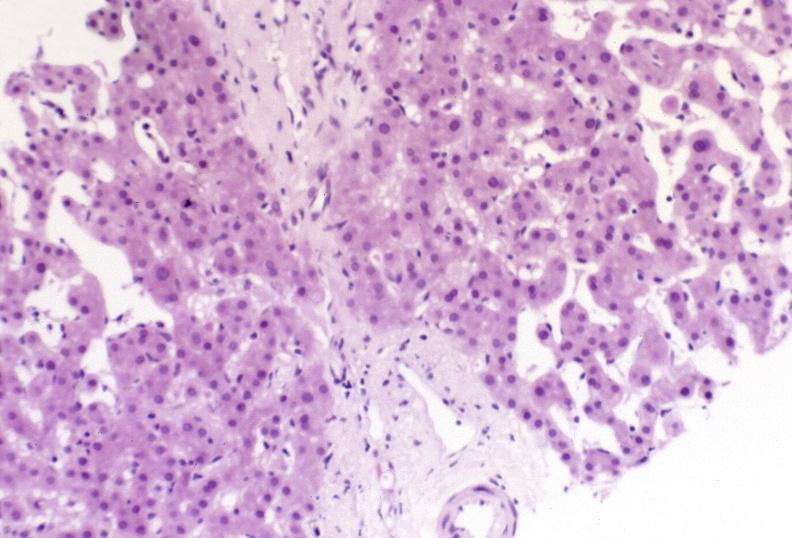s hepatobiliary present?
Answer the question using a single word or phrase. Yes 